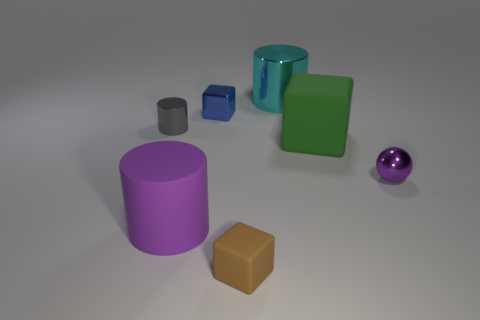Add 3 cyan metal cylinders. How many objects exist? 10 Subtract all cubes. How many objects are left? 4 Add 1 small brown matte blocks. How many small brown matte blocks are left? 2 Add 1 brown balls. How many brown balls exist? 1 Subtract 0 blue cylinders. How many objects are left? 7 Subtract all small blue metallic objects. Subtract all brown things. How many objects are left? 5 